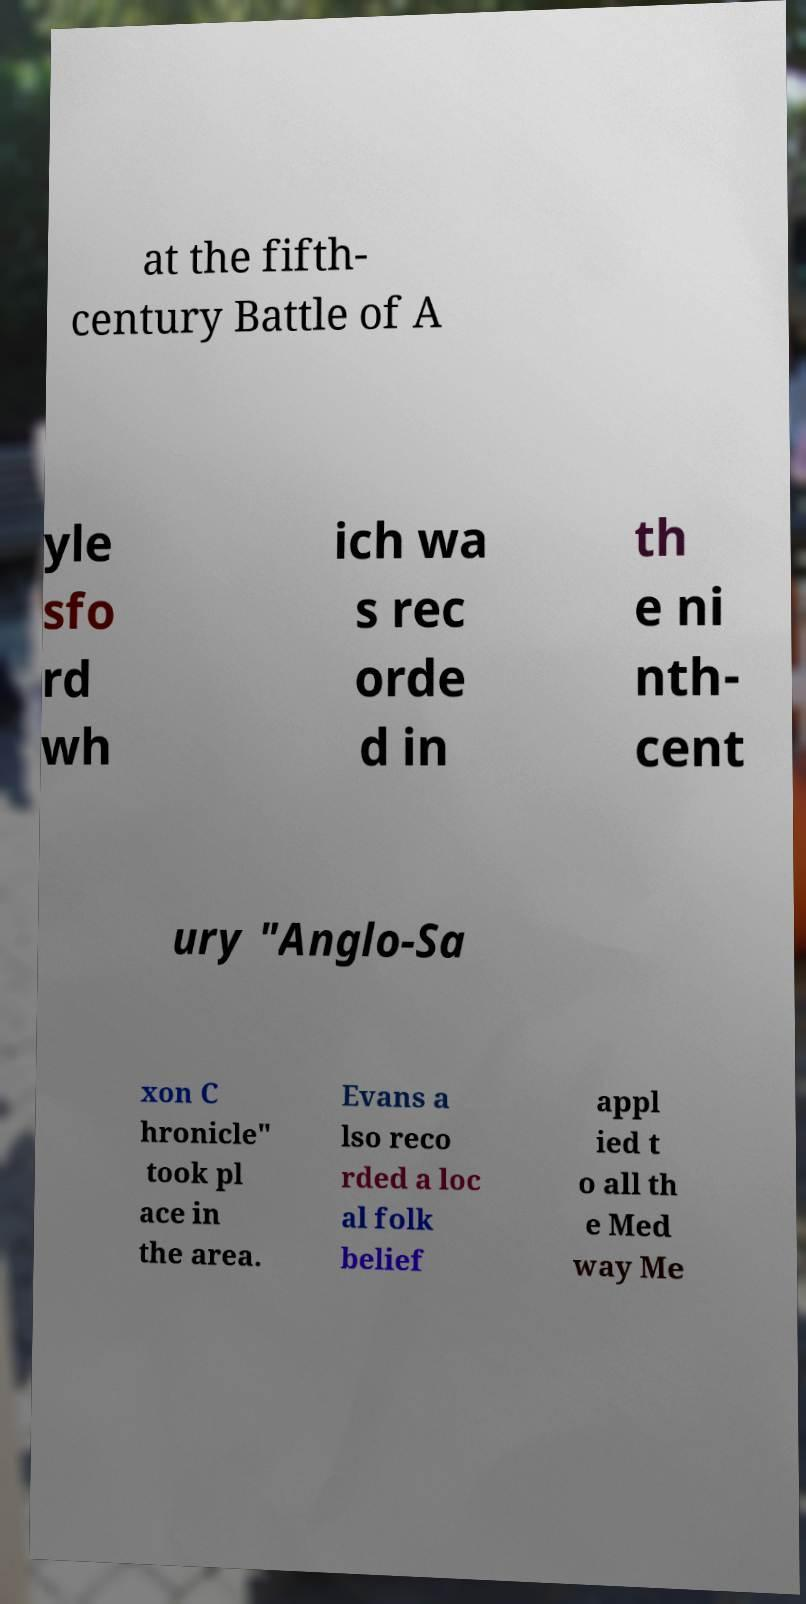Please read and relay the text visible in this image. What does it say? at the fifth- century Battle of A yle sfo rd wh ich wa s rec orde d in th e ni nth- cent ury "Anglo-Sa xon C hronicle" took pl ace in the area. Evans a lso reco rded a loc al folk belief appl ied t o all th e Med way Me 